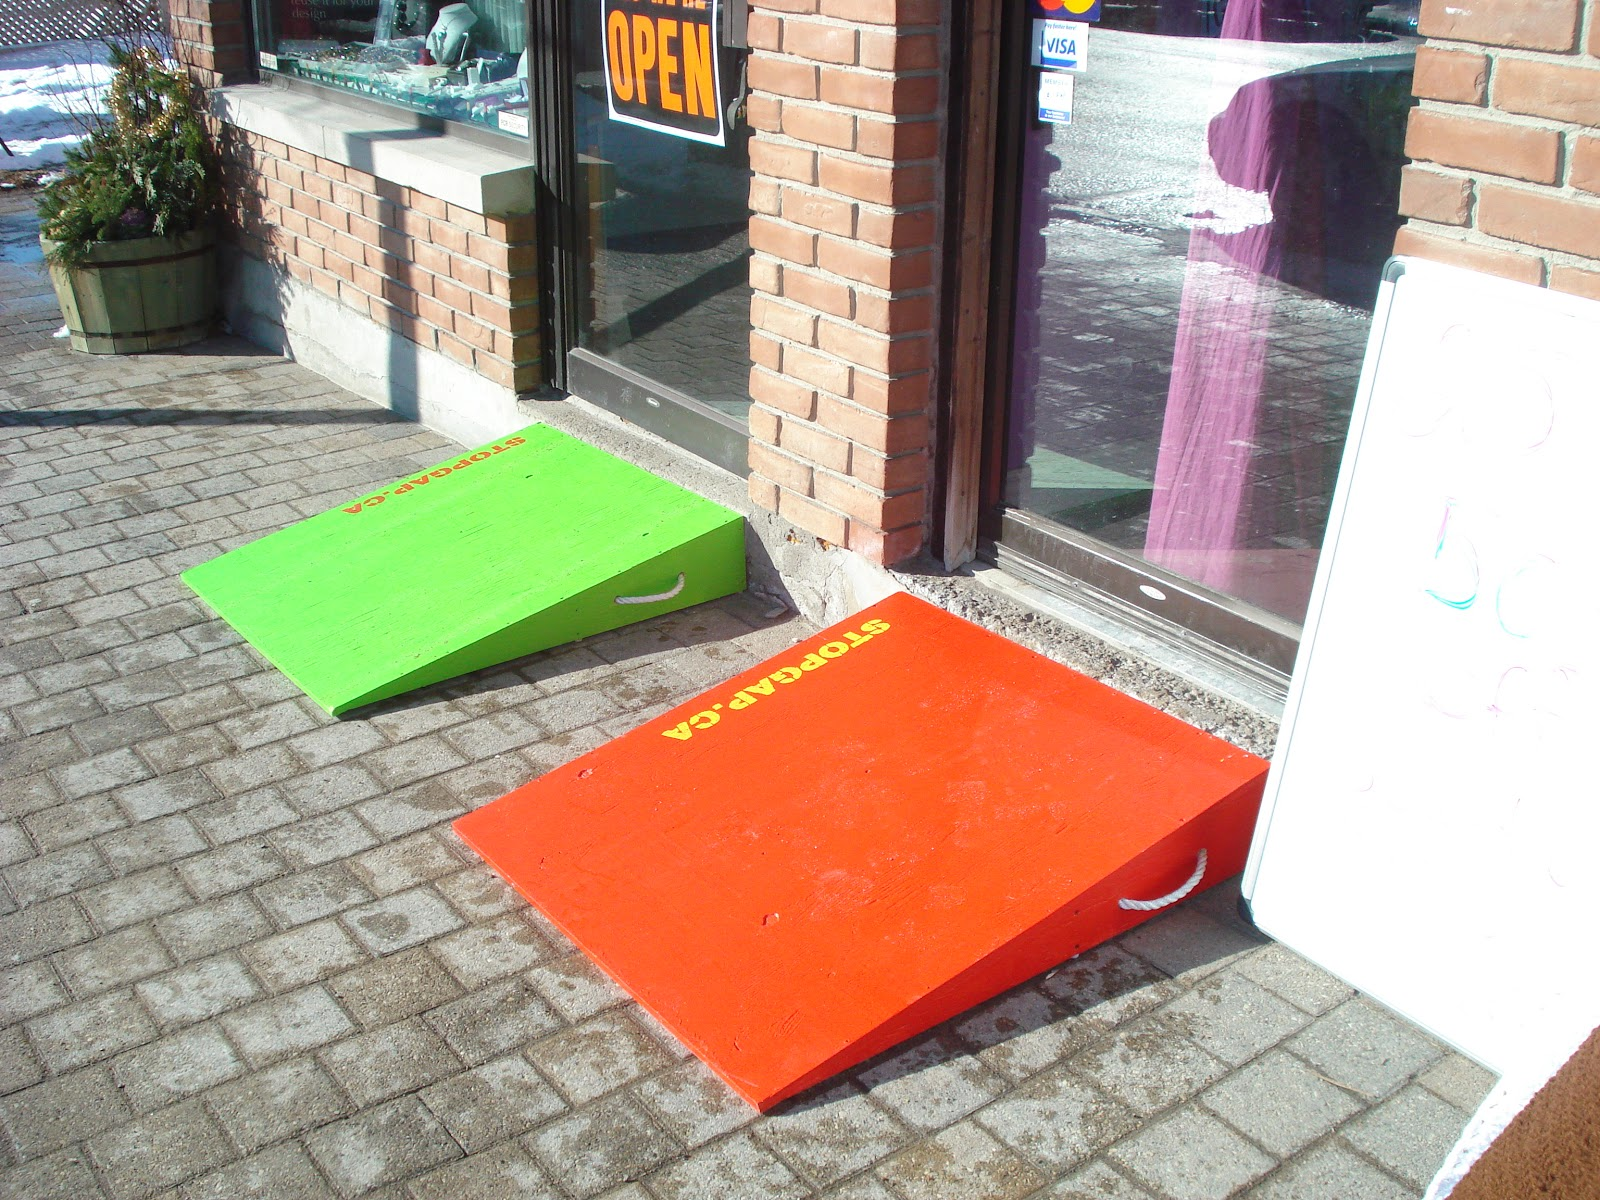Would a disabled wheelchair bound individual find it easy to go into this store? The store appears to have portable ramps, which are a positive step towards accessibility for wheelchair-bound individuals. However, there are a few considerations that could impact ease of access:

1. **Stability of Ramps**: Portable ramps need to be stable and securely placed to ensure safety. If not properly secured, they can be hazardous.
2. **Ramp Angle**: The steepness of the ramps will affect usability. ADA (Americans with Disabilities Act) guidelines suggest a maximum slope of 1:12 (for every inch of height, there should be 12 inches of ramp length).
3. **Width of Ramps**: The ramps should be wide enough to accommodate all types of wheelchairs.
4. **Threshold at Door**: The entrance should be flush with the ramp or have a smooth transition to prevent the wheelchair from getting stuck.
5. **Door Operation**: The door should be easy to open, ideally with an automatic opener or a handle that is easily reachable and operable by someone in a wheelchair.

While the presence of ramps is a good indicator, the overall accessibility would depend on these additional factors. 